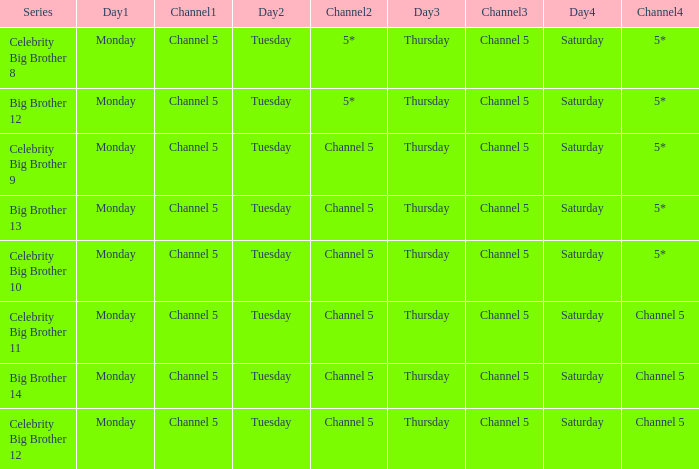Which program is aired on saturdays on channel 5? Celebrity Big Brother 11, Big Brother 14, Celebrity Big Brother 12. 